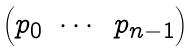<formula> <loc_0><loc_0><loc_500><loc_500>\begin{pmatrix} p _ { 0 } & \cdots & p _ { n - 1 } \end{pmatrix}</formula> 